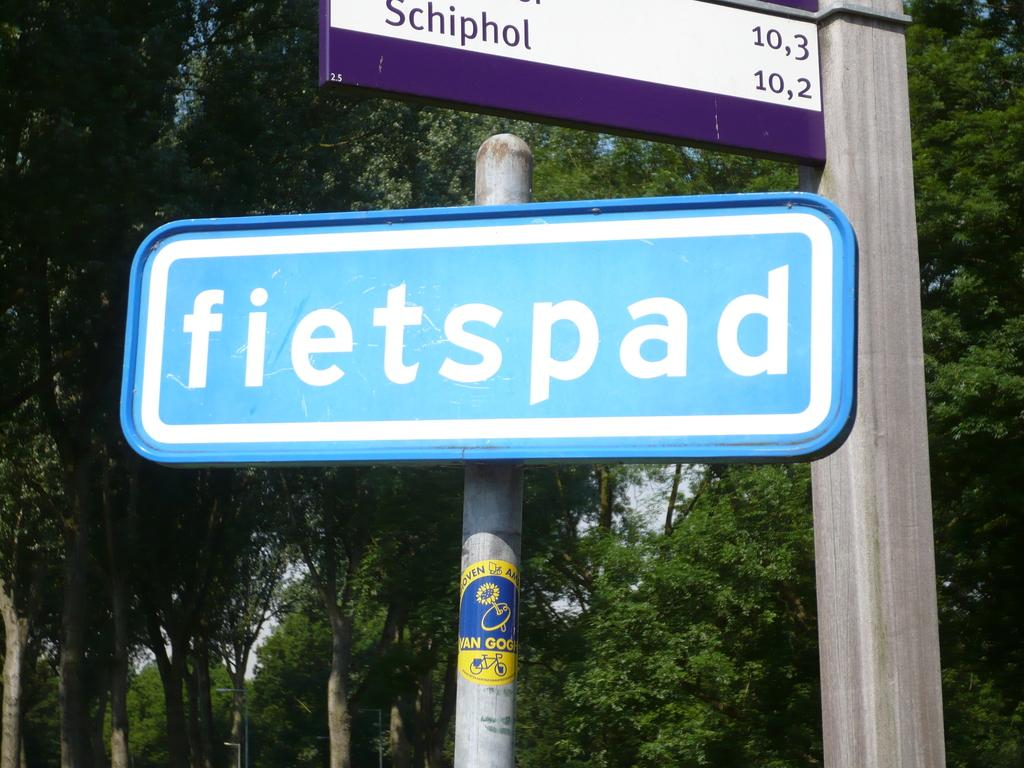What objects are present in the image? There are boards in the image. What can be seen in the background of the image? There are trees and the sky visible in the background of the image. What type of building can be seen in the image? There is no building present in the image; it only features boards and a background with trees and the sky. How much snow is visible on the ground in the image? There is no snow visible in the image; it only features boards, trees, and the sky. 